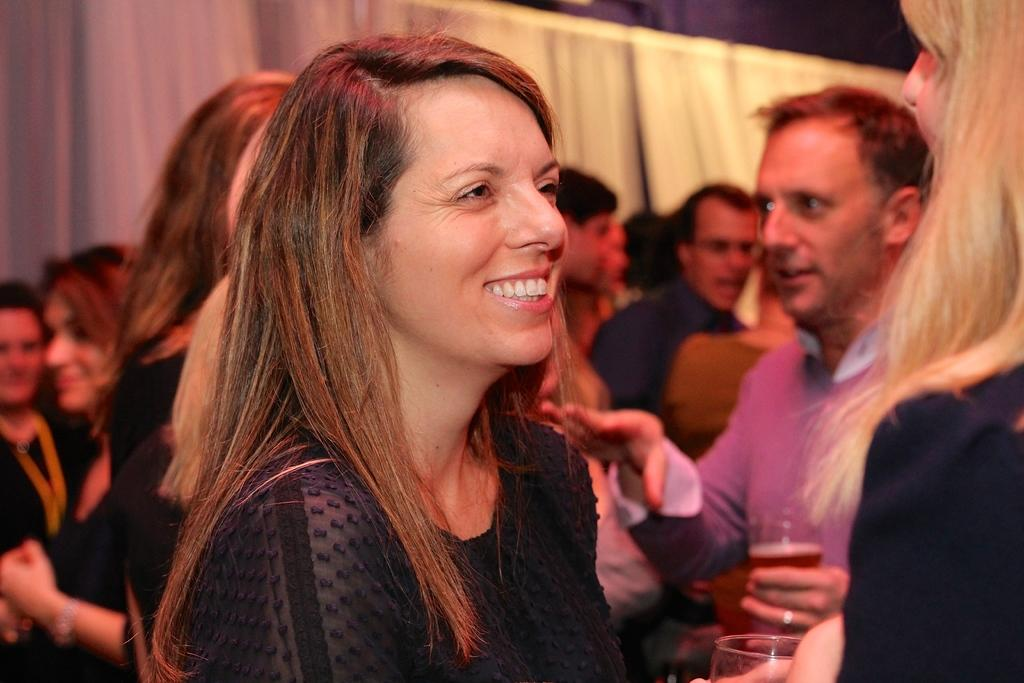What is the facial expression of the woman in the image? The woman in the image is smiling. Who is the woman looking at in the image? The woman is looking at an opposite person. How would you describe the background of the image? The background of the image is blurred. Can you describe any other people visible in the image? Yes, there are people visible in the background. What type of object can be seen in the background? There is a curtain in the background. What type of thrill can be seen in the image? There is no specific thrill depicted in the image; it features a woman smiling and looking at an opposite person. What time of day is it in the image? The provided facts do not mention the time of day, so it cannot be determined from the image. 